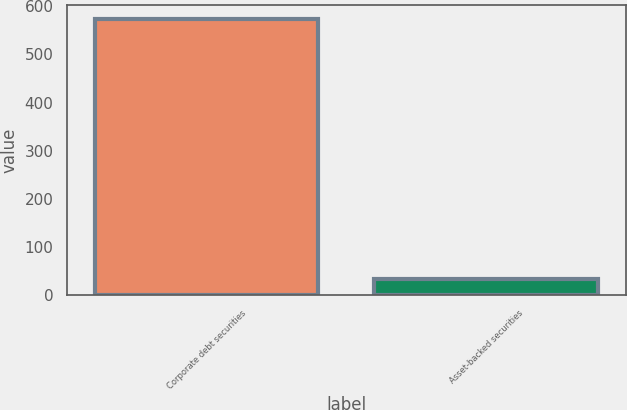Convert chart. <chart><loc_0><loc_0><loc_500><loc_500><bar_chart><fcel>Corporate debt securities<fcel>Asset-backed securities<nl><fcel>573<fcel>33<nl></chart> 